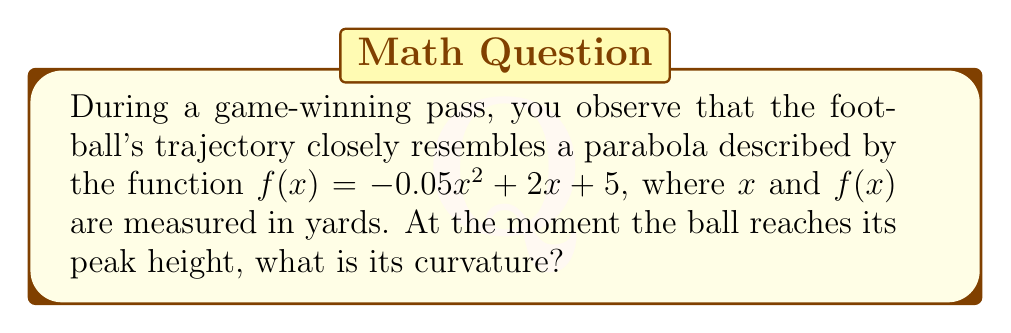Give your solution to this math problem. To determine the curvature of the football's trajectory at its peak, we'll follow these steps:

1) The curvature $\kappa$ of a function $f(x)$ at a point is given by:

   $$\kappa = \frac{|f''(x)|}{(1 + [f'(x)]^2)^{3/2}}$$

2) First, let's find $f'(x)$ and $f''(x)$:
   
   $f'(x) = -0.1x + 2$
   $f''(x) = -0.1$

3) At the peak of the trajectory, $f'(x) = 0$. Let's find this point:

   $-0.1x + 2 = 0$
   $x = 20$ yards

4) Now, we can calculate the curvature at $x = 20$:

   $$\kappa = \frac{|-0.1|}{(1 + [0]^2)^{3/2}} = 0.1$$

5) As a former NFL player, you might recognize that this curvature value indicates a relatively flat trajectory at the peak, which is typical for a well-thrown long pass.
Answer: $0.1$ yd$^{-1}$ 